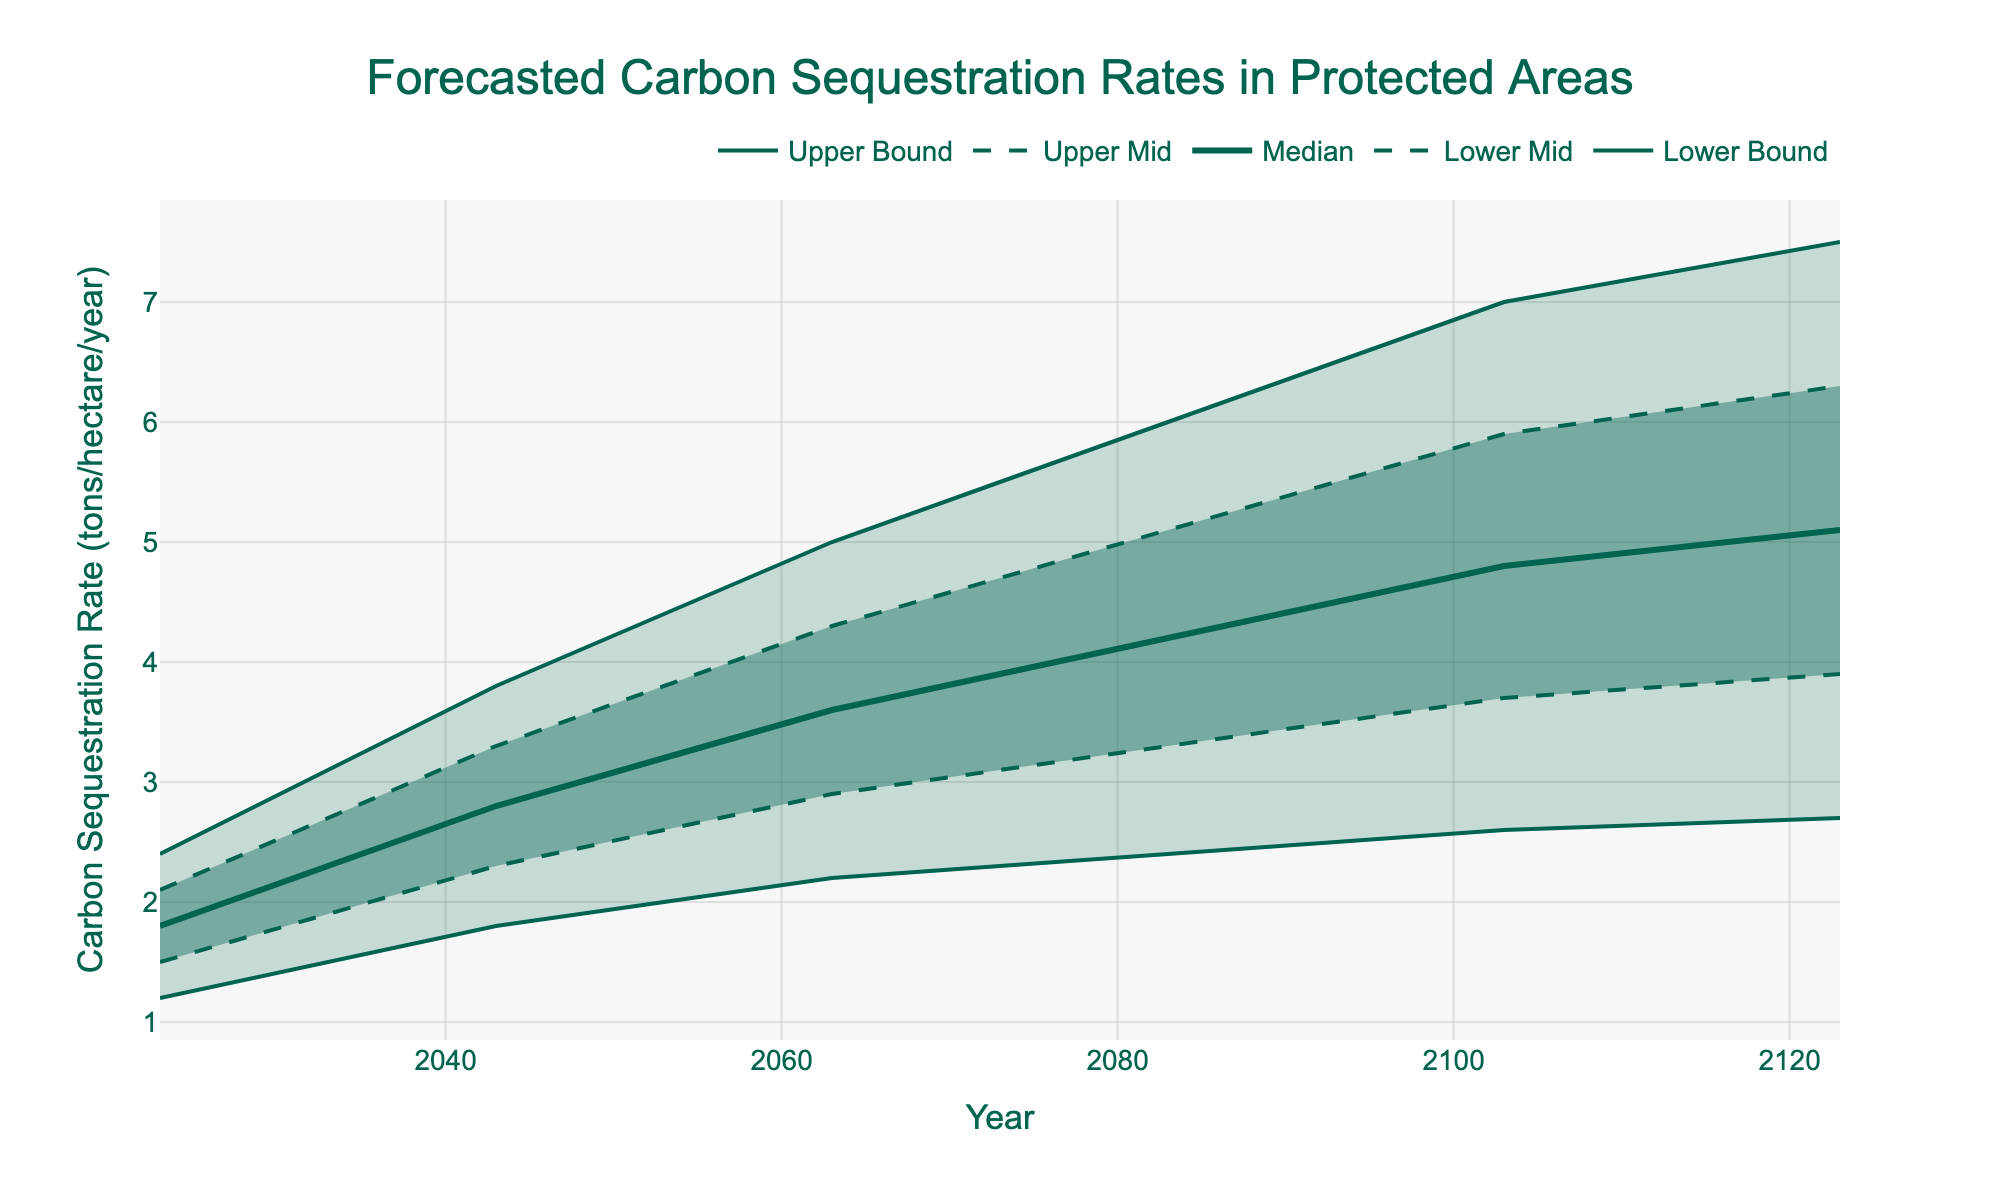What's the title of the chart? The title is usually placed at the top of the chart. Look for the largest text that describes what the chart is depicting.
Answer: Forecasted Carbon Sequestration Rates in Protected Areas What is the median sequestration rate projected for the year 2073? Locate the year 2073 on the x-axis and look for the corresponding value on the 'Median' line, which is typically the boldest line in the middle of the fan chart.
Answer: 3.9 tons/hectare/year By how much does the lower bound of the sequestration rate increase from 2023 to 2043? Identify the 'Lower Bound' values for 2023 and 2043 from the y-axis and subtract the 2023 value from the 2043 value (1.8 - 1.2).
Answer: 0.6 tons/hectare/year What is the range of the forecasted sequestration rate for the year 2053? The range is calculated as the difference between the 'Upper Bound' and 'Lower Bound' for 2053. Locate these values on the y-axis and subtract the lower from the upper (4.4 - 2.0).
Answer: 2.4 tons/hectare/year How does the upper mid sequestration rate for the year 2083 compare with the median rate for the same year? Locate 2083 on the x-axis and compare the corresponding 'Upper Mid’ value with the 'Median' value for that year.
Answer: The 'Upper Mid' value is 5.1 and the 'Median' value is 4.2, so it is higher by 0.9 tons/hectare/year Which year shows the highest upper bound in sequestration rates? Look for the year corresponding to the highest value on the 'Upper Bound' line, typically the topmost line in the chart.
Answer: 2123 What is the difference between the lower mid and median sequestration rates in 2093? Locate the 'Lower Mid' and 'Median' values for 2093 and subtract the 'Lower Mid' value from the 'Median’ value (4.5 - 3.5).
Answer: 1.0 tons/hectare/year Over which decade is the steepest increase in median sequestration rate observed? Observe the 'Median' line and identify the decade where the difference between starting and ending points is the greatest.
Answer: 2023-2033 